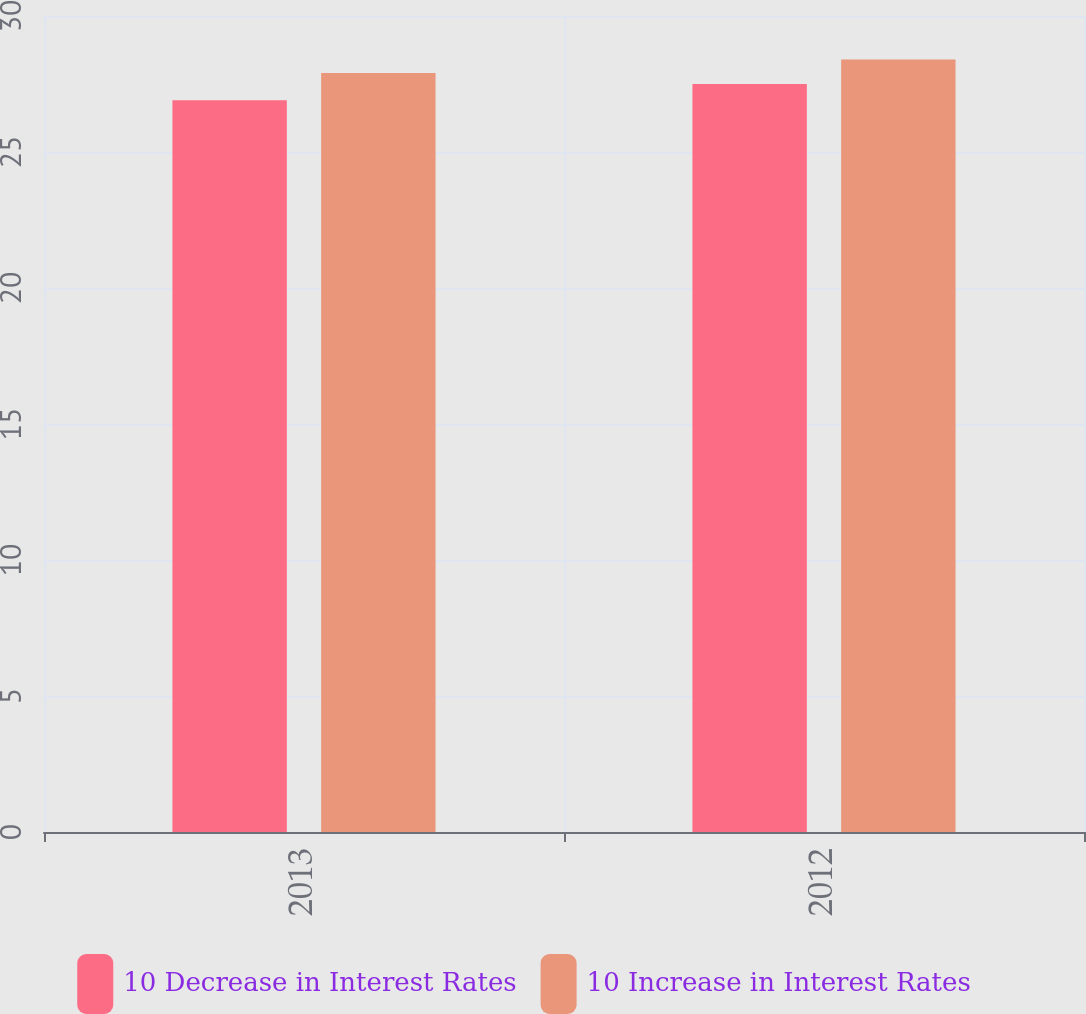Convert chart. <chart><loc_0><loc_0><loc_500><loc_500><stacked_bar_chart><ecel><fcel>2013<fcel>2012<nl><fcel>10 Decrease in Interest Rates<fcel>26.9<fcel>27.5<nl><fcel>10 Increase in Interest Rates<fcel>27.9<fcel>28.4<nl></chart> 